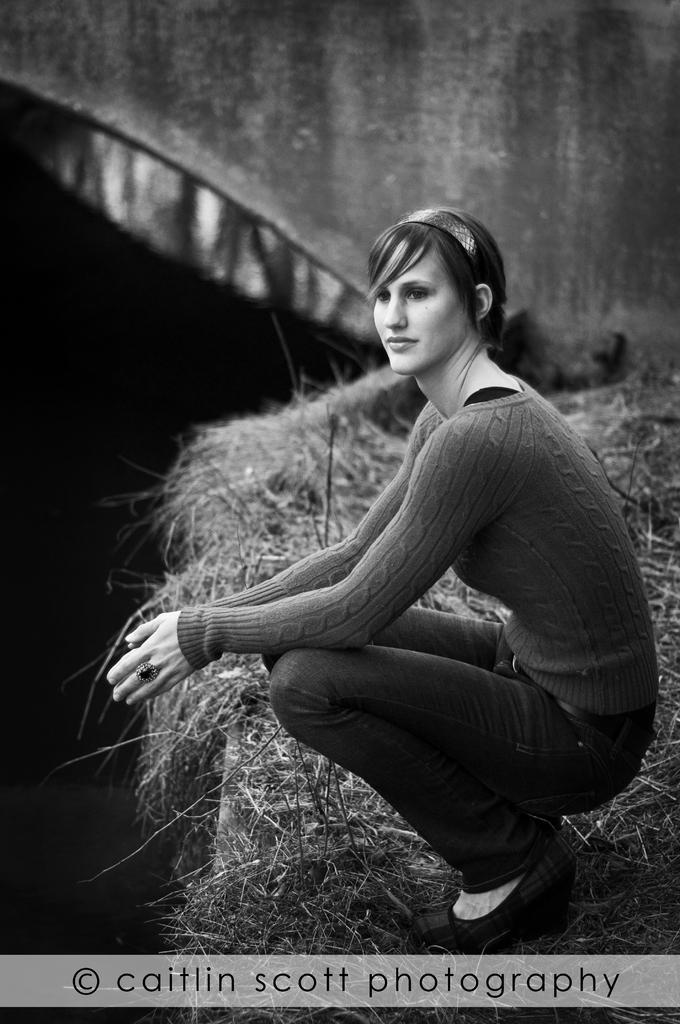Who is present in the image? There is a woman in the image. What is the woman wearing? The woman is wearing a T-shirt. What is the woman's facial expression? The woman is smiling. What position is the woman in, and what is she standing on? The woman is squatting on the grass. Can you describe any additional features in the image? There is a watermark in the image, and there is a wall in the background. What type of wine is the woman holding in the image? There is no wine present in the image; the woman is not holding any wine. 